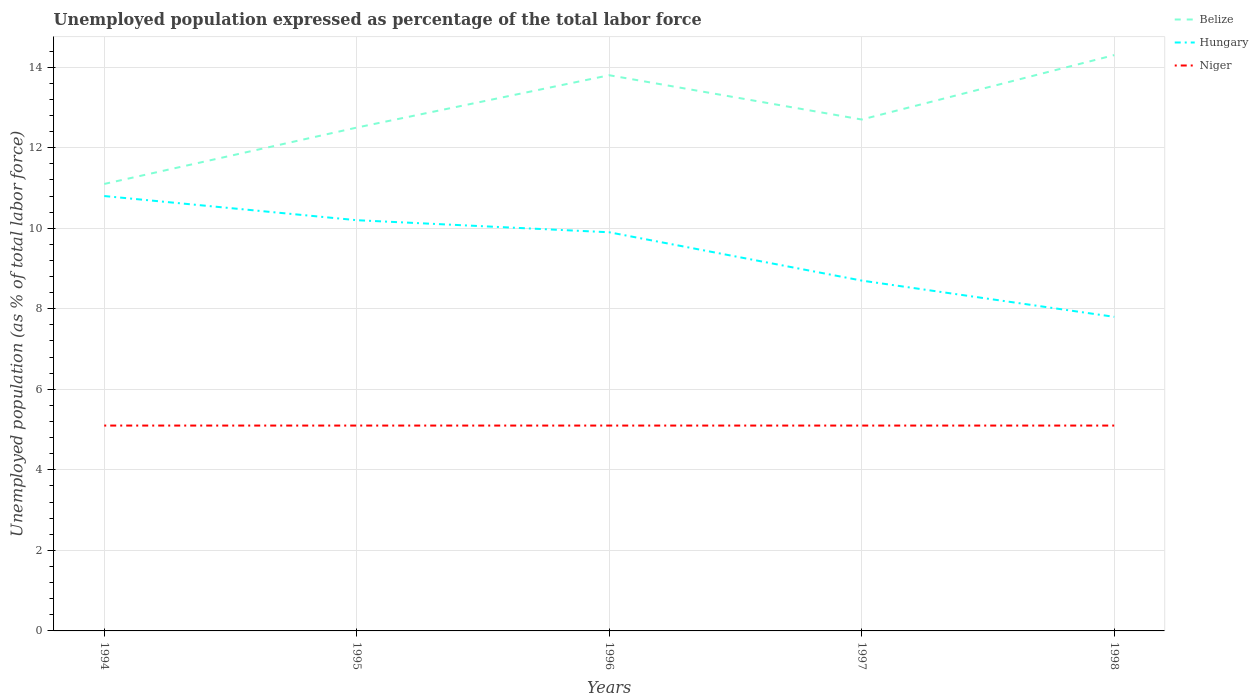How many different coloured lines are there?
Provide a succinct answer. 3. Is the number of lines equal to the number of legend labels?
Give a very brief answer. Yes. Across all years, what is the maximum unemployment in in Hungary?
Offer a very short reply. 7.8. What is the difference between the highest and the lowest unemployment in in Niger?
Offer a very short reply. 0. Is the unemployment in in Niger strictly greater than the unemployment in in Belize over the years?
Offer a very short reply. Yes. How many lines are there?
Your response must be concise. 3. What is the difference between two consecutive major ticks on the Y-axis?
Make the answer very short. 2. Are the values on the major ticks of Y-axis written in scientific E-notation?
Offer a terse response. No. Does the graph contain grids?
Make the answer very short. Yes. Where does the legend appear in the graph?
Give a very brief answer. Top right. How are the legend labels stacked?
Provide a short and direct response. Vertical. What is the title of the graph?
Give a very brief answer. Unemployed population expressed as percentage of the total labor force. Does "Europe(developing only)" appear as one of the legend labels in the graph?
Your response must be concise. No. What is the label or title of the Y-axis?
Offer a very short reply. Unemployed population (as % of total labor force). What is the Unemployed population (as % of total labor force) of Belize in 1994?
Your response must be concise. 11.1. What is the Unemployed population (as % of total labor force) in Hungary in 1994?
Give a very brief answer. 10.8. What is the Unemployed population (as % of total labor force) in Niger in 1994?
Keep it short and to the point. 5.1. What is the Unemployed population (as % of total labor force) of Belize in 1995?
Offer a very short reply. 12.5. What is the Unemployed population (as % of total labor force) of Hungary in 1995?
Provide a succinct answer. 10.2. What is the Unemployed population (as % of total labor force) of Niger in 1995?
Offer a terse response. 5.1. What is the Unemployed population (as % of total labor force) in Belize in 1996?
Your answer should be compact. 13.8. What is the Unemployed population (as % of total labor force) of Hungary in 1996?
Offer a very short reply. 9.9. What is the Unemployed population (as % of total labor force) in Niger in 1996?
Provide a succinct answer. 5.1. What is the Unemployed population (as % of total labor force) in Belize in 1997?
Provide a succinct answer. 12.7. What is the Unemployed population (as % of total labor force) of Hungary in 1997?
Your answer should be compact. 8.7. What is the Unemployed population (as % of total labor force) in Niger in 1997?
Keep it short and to the point. 5.1. What is the Unemployed population (as % of total labor force) of Belize in 1998?
Your response must be concise. 14.3. What is the Unemployed population (as % of total labor force) of Hungary in 1998?
Provide a succinct answer. 7.8. What is the Unemployed population (as % of total labor force) of Niger in 1998?
Make the answer very short. 5.1. Across all years, what is the maximum Unemployed population (as % of total labor force) of Belize?
Your answer should be compact. 14.3. Across all years, what is the maximum Unemployed population (as % of total labor force) in Hungary?
Offer a terse response. 10.8. Across all years, what is the maximum Unemployed population (as % of total labor force) in Niger?
Keep it short and to the point. 5.1. Across all years, what is the minimum Unemployed population (as % of total labor force) of Belize?
Provide a succinct answer. 11.1. Across all years, what is the minimum Unemployed population (as % of total labor force) in Hungary?
Your response must be concise. 7.8. Across all years, what is the minimum Unemployed population (as % of total labor force) of Niger?
Offer a terse response. 5.1. What is the total Unemployed population (as % of total labor force) of Belize in the graph?
Your response must be concise. 64.4. What is the total Unemployed population (as % of total labor force) of Hungary in the graph?
Ensure brevity in your answer.  47.4. What is the difference between the Unemployed population (as % of total labor force) in Hungary in 1994 and that in 1995?
Ensure brevity in your answer.  0.6. What is the difference between the Unemployed population (as % of total labor force) in Niger in 1994 and that in 1995?
Offer a terse response. 0. What is the difference between the Unemployed population (as % of total labor force) in Belize in 1994 and that in 1996?
Provide a succinct answer. -2.7. What is the difference between the Unemployed population (as % of total labor force) of Hungary in 1994 and that in 1996?
Your answer should be compact. 0.9. What is the difference between the Unemployed population (as % of total labor force) in Belize in 1994 and that in 1997?
Provide a succinct answer. -1.6. What is the difference between the Unemployed population (as % of total labor force) of Hungary in 1994 and that in 1997?
Keep it short and to the point. 2.1. What is the difference between the Unemployed population (as % of total labor force) in Niger in 1994 and that in 1997?
Your answer should be compact. 0. What is the difference between the Unemployed population (as % of total labor force) in Hungary in 1994 and that in 1998?
Give a very brief answer. 3. What is the difference between the Unemployed population (as % of total labor force) of Belize in 1995 and that in 1996?
Your answer should be compact. -1.3. What is the difference between the Unemployed population (as % of total labor force) of Belize in 1995 and that in 1997?
Give a very brief answer. -0.2. What is the difference between the Unemployed population (as % of total labor force) of Belize in 1995 and that in 1998?
Provide a succinct answer. -1.8. What is the difference between the Unemployed population (as % of total labor force) in Hungary in 1996 and that in 1997?
Keep it short and to the point. 1.2. What is the difference between the Unemployed population (as % of total labor force) in Belize in 1996 and that in 1998?
Make the answer very short. -0.5. What is the difference between the Unemployed population (as % of total labor force) in Niger in 1997 and that in 1998?
Ensure brevity in your answer.  0. What is the difference between the Unemployed population (as % of total labor force) in Belize in 1994 and the Unemployed population (as % of total labor force) in Hungary in 1995?
Make the answer very short. 0.9. What is the difference between the Unemployed population (as % of total labor force) of Hungary in 1994 and the Unemployed population (as % of total labor force) of Niger in 1995?
Give a very brief answer. 5.7. What is the difference between the Unemployed population (as % of total labor force) in Belize in 1994 and the Unemployed population (as % of total labor force) in Niger in 1996?
Offer a terse response. 6. What is the difference between the Unemployed population (as % of total labor force) of Belize in 1994 and the Unemployed population (as % of total labor force) of Hungary in 1997?
Offer a terse response. 2.4. What is the difference between the Unemployed population (as % of total labor force) in Belize in 1994 and the Unemployed population (as % of total labor force) in Hungary in 1998?
Offer a terse response. 3.3. What is the difference between the Unemployed population (as % of total labor force) of Belize in 1994 and the Unemployed population (as % of total labor force) of Niger in 1998?
Provide a short and direct response. 6. What is the difference between the Unemployed population (as % of total labor force) of Hungary in 1994 and the Unemployed population (as % of total labor force) of Niger in 1998?
Provide a short and direct response. 5.7. What is the difference between the Unemployed population (as % of total labor force) in Hungary in 1995 and the Unemployed population (as % of total labor force) in Niger in 1996?
Your answer should be very brief. 5.1. What is the difference between the Unemployed population (as % of total labor force) of Belize in 1995 and the Unemployed population (as % of total labor force) of Niger in 1997?
Keep it short and to the point. 7.4. What is the difference between the Unemployed population (as % of total labor force) in Belize in 1996 and the Unemployed population (as % of total labor force) in Hungary in 1997?
Give a very brief answer. 5.1. What is the difference between the Unemployed population (as % of total labor force) of Belize in 1996 and the Unemployed population (as % of total labor force) of Niger in 1997?
Keep it short and to the point. 8.7. What is the difference between the Unemployed population (as % of total labor force) in Hungary in 1996 and the Unemployed population (as % of total labor force) in Niger in 1997?
Your response must be concise. 4.8. What is the difference between the Unemployed population (as % of total labor force) in Belize in 1996 and the Unemployed population (as % of total labor force) in Hungary in 1998?
Offer a terse response. 6. What is the difference between the Unemployed population (as % of total labor force) in Belize in 1996 and the Unemployed population (as % of total labor force) in Niger in 1998?
Your answer should be very brief. 8.7. What is the difference between the Unemployed population (as % of total labor force) of Hungary in 1996 and the Unemployed population (as % of total labor force) of Niger in 1998?
Provide a succinct answer. 4.8. What is the difference between the Unemployed population (as % of total labor force) in Belize in 1997 and the Unemployed population (as % of total labor force) in Hungary in 1998?
Your answer should be very brief. 4.9. What is the difference between the Unemployed population (as % of total labor force) of Hungary in 1997 and the Unemployed population (as % of total labor force) of Niger in 1998?
Your answer should be very brief. 3.6. What is the average Unemployed population (as % of total labor force) of Belize per year?
Offer a terse response. 12.88. What is the average Unemployed population (as % of total labor force) in Hungary per year?
Make the answer very short. 9.48. In the year 1995, what is the difference between the Unemployed population (as % of total labor force) of Belize and Unemployed population (as % of total labor force) of Niger?
Give a very brief answer. 7.4. In the year 1997, what is the difference between the Unemployed population (as % of total labor force) of Belize and Unemployed population (as % of total labor force) of Hungary?
Offer a very short reply. 4. In the year 1997, what is the difference between the Unemployed population (as % of total labor force) in Belize and Unemployed population (as % of total labor force) in Niger?
Make the answer very short. 7.6. In the year 1998, what is the difference between the Unemployed population (as % of total labor force) of Belize and Unemployed population (as % of total labor force) of Hungary?
Give a very brief answer. 6.5. In the year 1998, what is the difference between the Unemployed population (as % of total labor force) in Belize and Unemployed population (as % of total labor force) in Niger?
Give a very brief answer. 9.2. What is the ratio of the Unemployed population (as % of total labor force) in Belize in 1994 to that in 1995?
Your response must be concise. 0.89. What is the ratio of the Unemployed population (as % of total labor force) in Hungary in 1994 to that in 1995?
Your answer should be very brief. 1.06. What is the ratio of the Unemployed population (as % of total labor force) of Niger in 1994 to that in 1995?
Provide a short and direct response. 1. What is the ratio of the Unemployed population (as % of total labor force) in Belize in 1994 to that in 1996?
Offer a very short reply. 0.8. What is the ratio of the Unemployed population (as % of total labor force) in Hungary in 1994 to that in 1996?
Your response must be concise. 1.09. What is the ratio of the Unemployed population (as % of total labor force) of Belize in 1994 to that in 1997?
Keep it short and to the point. 0.87. What is the ratio of the Unemployed population (as % of total labor force) of Hungary in 1994 to that in 1997?
Provide a short and direct response. 1.24. What is the ratio of the Unemployed population (as % of total labor force) of Niger in 1994 to that in 1997?
Keep it short and to the point. 1. What is the ratio of the Unemployed population (as % of total labor force) of Belize in 1994 to that in 1998?
Offer a terse response. 0.78. What is the ratio of the Unemployed population (as % of total labor force) of Hungary in 1994 to that in 1998?
Ensure brevity in your answer.  1.38. What is the ratio of the Unemployed population (as % of total labor force) in Belize in 1995 to that in 1996?
Your response must be concise. 0.91. What is the ratio of the Unemployed population (as % of total labor force) of Hungary in 1995 to that in 1996?
Ensure brevity in your answer.  1.03. What is the ratio of the Unemployed population (as % of total labor force) of Belize in 1995 to that in 1997?
Provide a short and direct response. 0.98. What is the ratio of the Unemployed population (as % of total labor force) in Hungary in 1995 to that in 1997?
Offer a terse response. 1.17. What is the ratio of the Unemployed population (as % of total labor force) of Niger in 1995 to that in 1997?
Your response must be concise. 1. What is the ratio of the Unemployed population (as % of total labor force) in Belize in 1995 to that in 1998?
Your response must be concise. 0.87. What is the ratio of the Unemployed population (as % of total labor force) of Hungary in 1995 to that in 1998?
Your response must be concise. 1.31. What is the ratio of the Unemployed population (as % of total labor force) of Niger in 1995 to that in 1998?
Your response must be concise. 1. What is the ratio of the Unemployed population (as % of total labor force) of Belize in 1996 to that in 1997?
Ensure brevity in your answer.  1.09. What is the ratio of the Unemployed population (as % of total labor force) of Hungary in 1996 to that in 1997?
Provide a succinct answer. 1.14. What is the ratio of the Unemployed population (as % of total labor force) in Belize in 1996 to that in 1998?
Provide a succinct answer. 0.96. What is the ratio of the Unemployed population (as % of total labor force) in Hungary in 1996 to that in 1998?
Offer a terse response. 1.27. What is the ratio of the Unemployed population (as % of total labor force) in Niger in 1996 to that in 1998?
Provide a succinct answer. 1. What is the ratio of the Unemployed population (as % of total labor force) in Belize in 1997 to that in 1998?
Ensure brevity in your answer.  0.89. What is the ratio of the Unemployed population (as % of total labor force) in Hungary in 1997 to that in 1998?
Provide a succinct answer. 1.12. What is the ratio of the Unemployed population (as % of total labor force) in Niger in 1997 to that in 1998?
Provide a short and direct response. 1. What is the difference between the highest and the lowest Unemployed population (as % of total labor force) in Belize?
Ensure brevity in your answer.  3.2. 